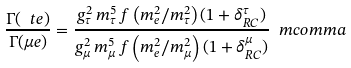<formula> <loc_0><loc_0><loc_500><loc_500>\frac { \Gamma ( \ t e ) } { \Gamma ( \mu e ) } = \frac { g _ { \tau } ^ { 2 } \, m _ { \tau } ^ { 5 } \, f \left ( m _ { e } ^ { 2 } / m _ { \tau } ^ { 2 } \right ) ( 1 + \delta _ { R C } ^ { \tau } ) } { g _ { \mu } ^ { 2 } \, m _ { \mu } ^ { 5 } \, f \left ( m _ { e } ^ { 2 } / m _ { \mu } ^ { 2 } \right ) ( 1 + \delta _ { R C } ^ { \mu } ) } \ m c o m m a</formula> 